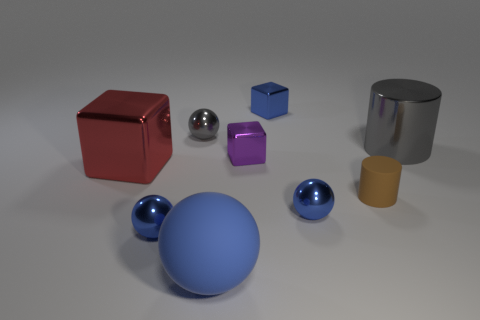Subtract all blue spheres. How many were subtracted if there are1blue spheres left? 2 Subtract all yellow cylinders. How many blue spheres are left? 3 Add 1 large gray shiny balls. How many objects exist? 10 Subtract all blocks. How many objects are left? 6 Add 4 large red metal blocks. How many large red metal blocks are left? 5 Add 1 tiny yellow metallic cubes. How many tiny yellow metallic cubes exist? 1 Subtract 0 brown balls. How many objects are left? 9 Subtract all green metallic objects. Subtract all blue metallic balls. How many objects are left? 7 